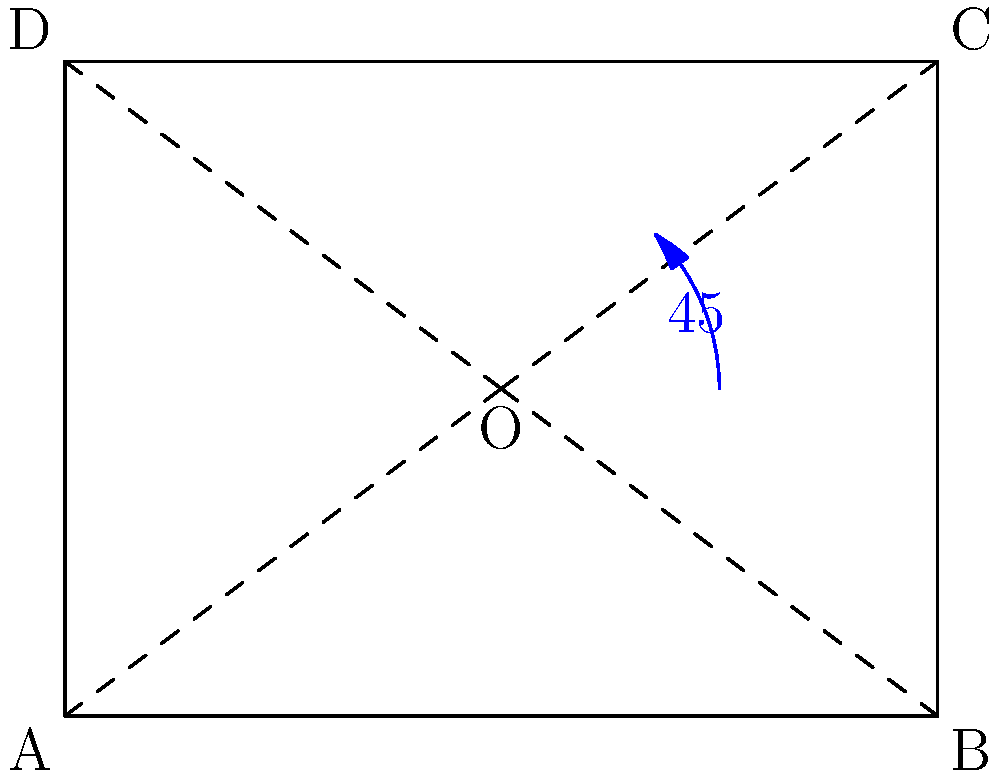In an automated storage system, a rectangular container with dimensions 4 units by 3 units needs to be rotated to optimize space utilization. If the container is rotated 45° counterclockwise around its center point O, what is the new area occupied by the rotated container? To find the area occupied by the rotated container, we need to follow these steps:

1. Identify the dimensions of the original rectangle:
   Length (l) = 4 units
   Width (w) = 3 units

2. Calculate the diagonal of the rectangle using the Pythagorean theorem:
   $$d = \sqrt{l^2 + w^2} = \sqrt{4^2 + 3^2} = \sqrt{16 + 9} = \sqrt{25} = 5$$ units

3. The diagonal of the rectangle becomes the side of the square that encloses the rotated rectangle. Therefore, the area occupied by the rotated container is:
   $$A = d^2 = 5^2 = 25$$ square units

4. Note that this rotation maximizes the occupied area, which may seem counterintuitive for space optimization. However, in automated storage systems, this rotation might be necessary for other factors such as accessibility or alignment with handling equipment.

5. The difference in occupied area is:
   $$25 - (4 * 3) = 25 - 12 = 13$$ square units

This increase in occupied area highlights the importance of considering rotational transformations in automated storage system design to balance space utilization with operational requirements.
Answer: 25 square units 